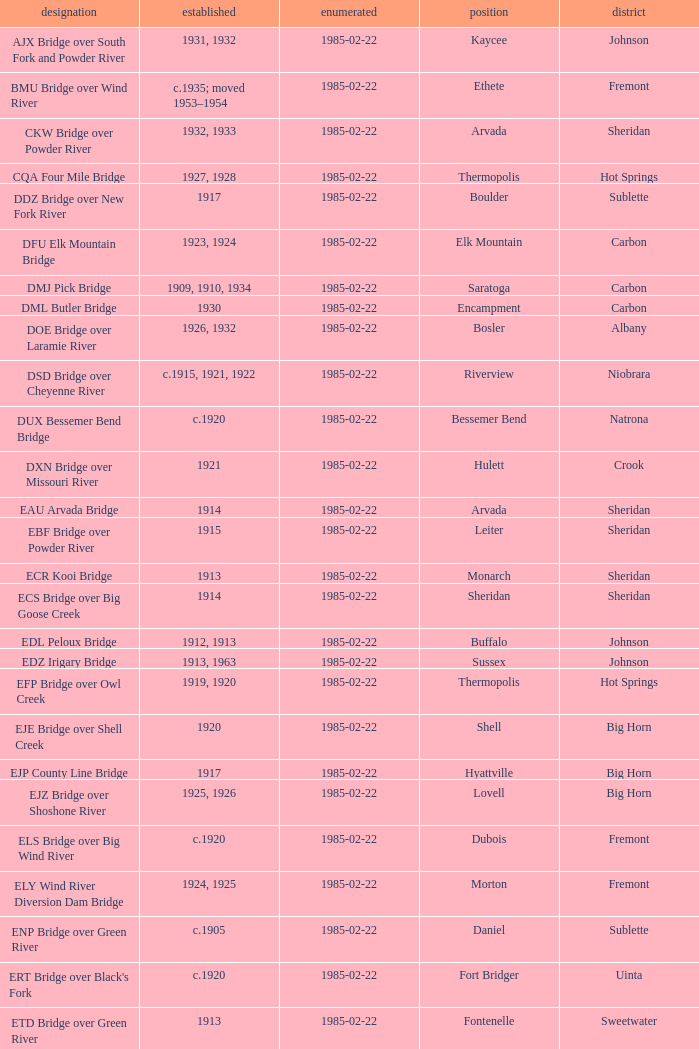What is the county of the bridge in Boulder? Sublette. 